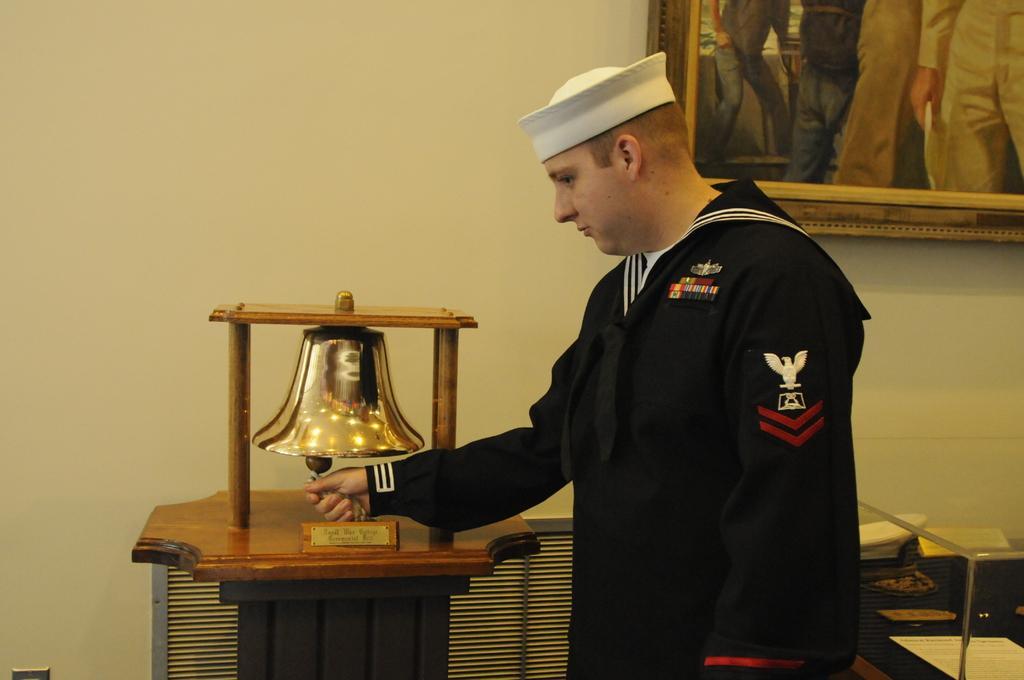In one or two sentences, can you explain what this image depicts? In this image there is a person is ringing the bell, behind the person on the wall there is a wooden photo frame. 